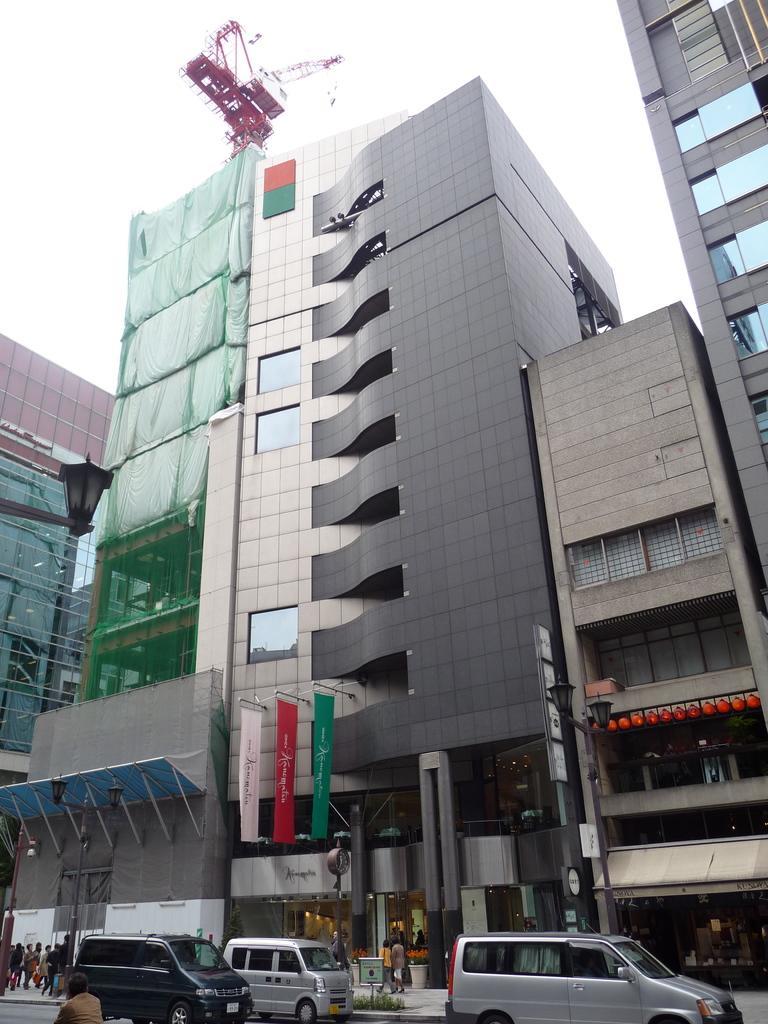How would you summarize this image in a sentence or two? In this picture, there are buildings in the center. At the bottom, there are vehicles which are in different colors. In between the vehicles, there are people. Towards the bottom left, there are some more people. At the top, there is a sky. 